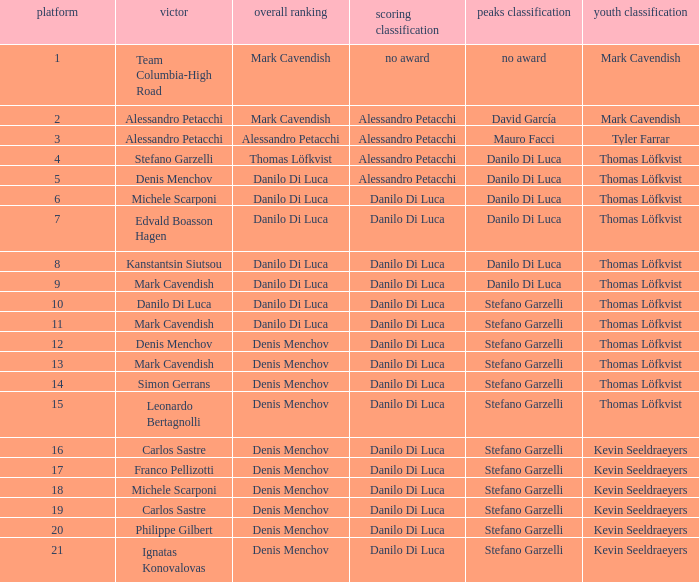When 19 is the stage who is the points classification? Danilo Di Luca. 